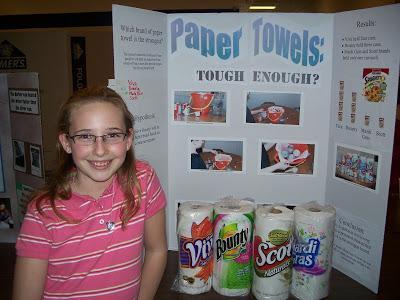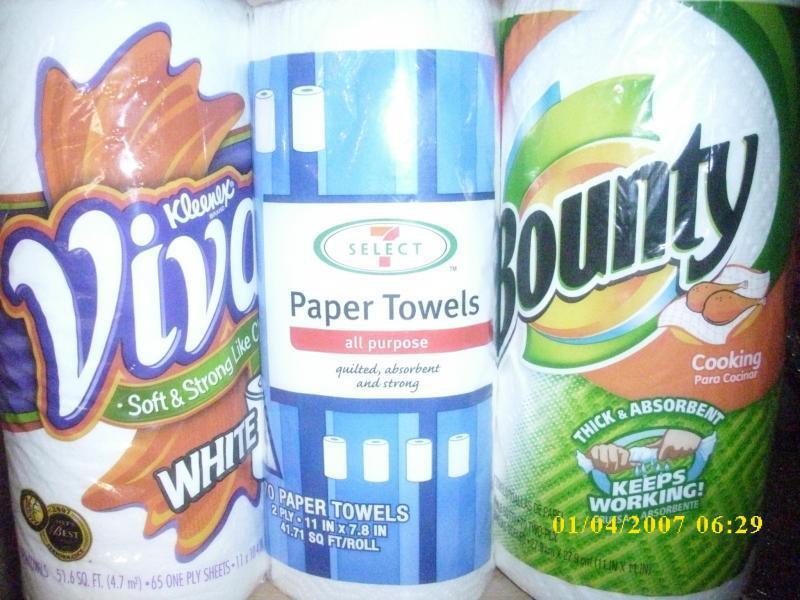The first image is the image on the left, the second image is the image on the right. Examine the images to the left and right. Is the description "One image shows an upright poster for a school science fair project, while a second image shows at least three wrapped rolls of paper towels, all different brands." accurate? Answer yes or no. Yes. The first image is the image on the left, the second image is the image on the right. Examine the images to the left and right. Is the description "One image shows a poster with consumer items in front of it, and the other image shows individiually wrapped paper towel rolls." accurate? Answer yes or no. Yes. 